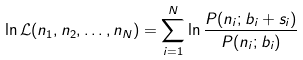<formula> <loc_0><loc_0><loc_500><loc_500>\ln \mathcal { L } ( n _ { 1 } , n _ { 2 } , \dots , n _ { N } ) = \sum _ { i = 1 } ^ { N } \ln \frac { P ( n _ { i } ; b _ { i } + s _ { i } ) } { P ( n _ { i } ; b _ { i } ) }</formula> 